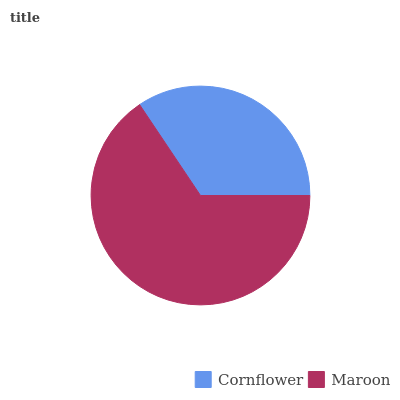Is Cornflower the minimum?
Answer yes or no. Yes. Is Maroon the maximum?
Answer yes or no. Yes. Is Maroon the minimum?
Answer yes or no. No. Is Maroon greater than Cornflower?
Answer yes or no. Yes. Is Cornflower less than Maroon?
Answer yes or no. Yes. Is Cornflower greater than Maroon?
Answer yes or no. No. Is Maroon less than Cornflower?
Answer yes or no. No. Is Maroon the high median?
Answer yes or no. Yes. Is Cornflower the low median?
Answer yes or no. Yes. Is Cornflower the high median?
Answer yes or no. No. Is Maroon the low median?
Answer yes or no. No. 